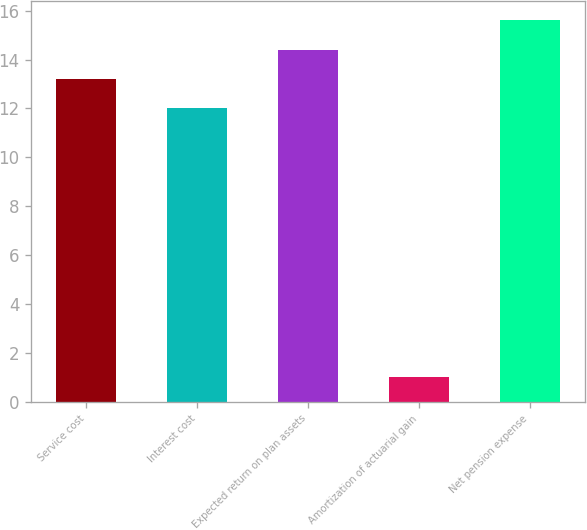Convert chart to OTSL. <chart><loc_0><loc_0><loc_500><loc_500><bar_chart><fcel>Service cost<fcel>Interest cost<fcel>Expected return on plan assets<fcel>Amortization of actuarial gain<fcel>Net pension expense<nl><fcel>13.2<fcel>12<fcel>14.4<fcel>1<fcel>15.6<nl></chart> 